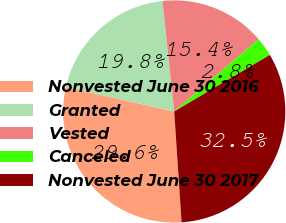Convert chart to OTSL. <chart><loc_0><loc_0><loc_500><loc_500><pie_chart><fcel>Nonvested June 30 2016<fcel>Granted<fcel>Vested<fcel>Canceled<fcel>Nonvested June 30 2017<nl><fcel>29.6%<fcel>19.77%<fcel>15.42%<fcel>2.76%<fcel>32.45%<nl></chart> 